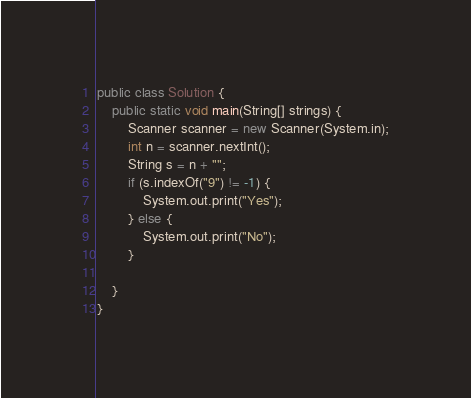<code> <loc_0><loc_0><loc_500><loc_500><_C++_>public class Solution {
    public static void main(String[] strings) {
        Scanner scanner = new Scanner(System.in);
        int n = scanner.nextInt();
        String s = n + "";
        if (s.indexOf("9") != -1) {
            System.out.print("Yes");
        } else {
            System.out.print("No");
        }

    }
}</code> 